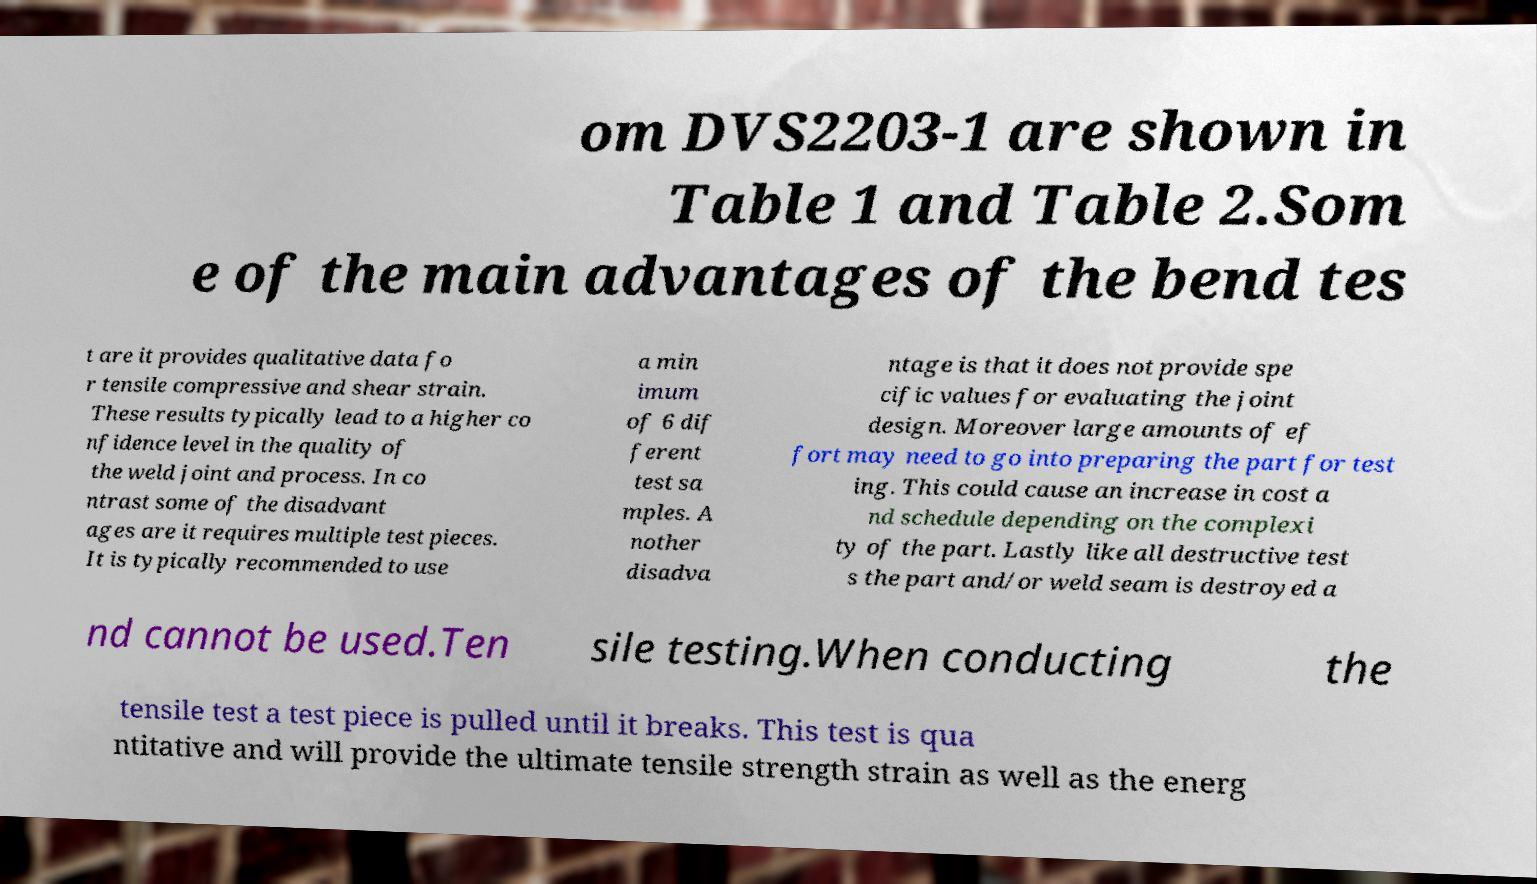For documentation purposes, I need the text within this image transcribed. Could you provide that? om DVS2203-1 are shown in Table 1 and Table 2.Som e of the main advantages of the bend tes t are it provides qualitative data fo r tensile compressive and shear strain. These results typically lead to a higher co nfidence level in the quality of the weld joint and process. In co ntrast some of the disadvant ages are it requires multiple test pieces. It is typically recommended to use a min imum of 6 dif ferent test sa mples. A nother disadva ntage is that it does not provide spe cific values for evaluating the joint design. Moreover large amounts of ef fort may need to go into preparing the part for test ing. This could cause an increase in cost a nd schedule depending on the complexi ty of the part. Lastly like all destructive test s the part and/or weld seam is destroyed a nd cannot be used.Ten sile testing.When conducting the tensile test a test piece is pulled until it breaks. This test is qua ntitative and will provide the ultimate tensile strength strain as well as the energ 